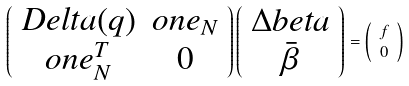Convert formula to latex. <formula><loc_0><loc_0><loc_500><loc_500>\left ( \begin{array} { c c } D e l t a ( q ) & o n e _ { N } \\ o n e _ { N } ^ { T } & 0 \end{array} \right ) \left ( \begin{array} { c } \Delta b e t a \\ \bar { \beta } \end{array} \right ) & = \left ( \begin{array} { c } f \\ 0 \end{array} \right )</formula> 